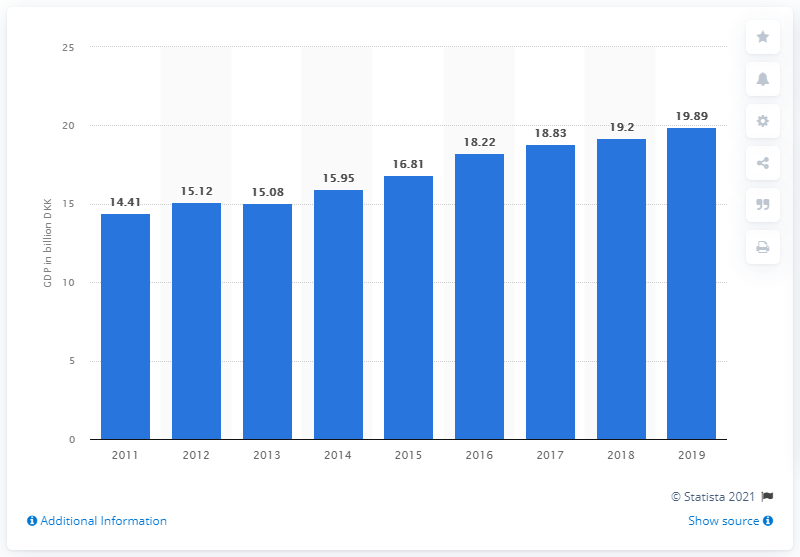Mention a couple of crucial points in this snapshot. In 2011, the GDP of Greenland increased from 14 billion Danish kroner to nearly 20 billion Danish kroner. In 2019, the Gross Domestic Product (GDP) of Greenland was 19.89 billion U.S. dollars. 